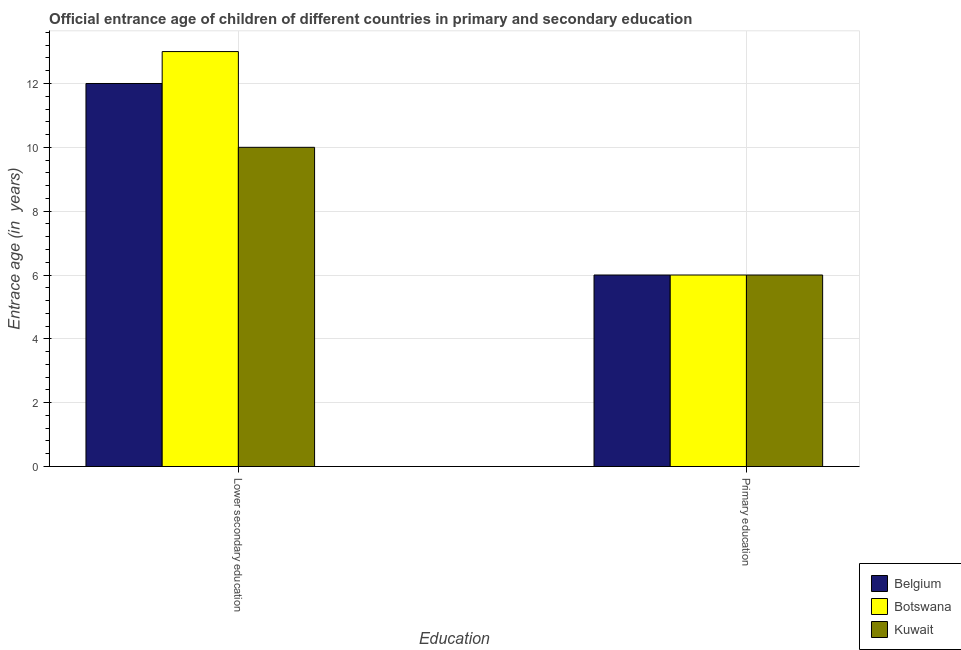How many different coloured bars are there?
Keep it short and to the point. 3. How many groups of bars are there?
Make the answer very short. 2. Are the number of bars on each tick of the X-axis equal?
Make the answer very short. Yes. How many bars are there on the 1st tick from the left?
Ensure brevity in your answer.  3. How many bars are there on the 2nd tick from the right?
Your answer should be compact. 3. What is the label of the 1st group of bars from the left?
Your answer should be very brief. Lower secondary education. What is the entrance age of chiildren in primary education in Belgium?
Keep it short and to the point. 6. Across all countries, what is the maximum entrance age of chiildren in primary education?
Your response must be concise. 6. Across all countries, what is the minimum entrance age of chiildren in primary education?
Make the answer very short. 6. In which country was the entrance age of children in lower secondary education maximum?
Your response must be concise. Botswana. In which country was the entrance age of chiildren in primary education minimum?
Give a very brief answer. Belgium. What is the total entrance age of chiildren in primary education in the graph?
Keep it short and to the point. 18. What is the difference between the entrance age of chiildren in primary education in Kuwait and that in Botswana?
Offer a terse response. 0. What is the difference between the entrance age of chiildren in primary education in Kuwait and the entrance age of children in lower secondary education in Belgium?
Offer a terse response. -6. What is the average entrance age of children in lower secondary education per country?
Make the answer very short. 11.67. In how many countries, is the entrance age of children in lower secondary education greater than 8 years?
Provide a short and direct response. 3. What is the ratio of the entrance age of chiildren in primary education in Belgium to that in Botswana?
Give a very brief answer. 1. Is the entrance age of chiildren in primary education in Botswana less than that in Kuwait?
Ensure brevity in your answer.  No. In how many countries, is the entrance age of children in lower secondary education greater than the average entrance age of children in lower secondary education taken over all countries?
Your answer should be very brief. 2. What does the 3rd bar from the left in Lower secondary education represents?
Provide a short and direct response. Kuwait. Are all the bars in the graph horizontal?
Provide a succinct answer. No. How many countries are there in the graph?
Make the answer very short. 3. What is the difference between two consecutive major ticks on the Y-axis?
Your response must be concise. 2. Are the values on the major ticks of Y-axis written in scientific E-notation?
Your response must be concise. No. Does the graph contain grids?
Provide a short and direct response. Yes. Where does the legend appear in the graph?
Provide a succinct answer. Bottom right. How many legend labels are there?
Make the answer very short. 3. What is the title of the graph?
Ensure brevity in your answer.  Official entrance age of children of different countries in primary and secondary education. Does "Serbia" appear as one of the legend labels in the graph?
Keep it short and to the point. No. What is the label or title of the X-axis?
Offer a very short reply. Education. What is the label or title of the Y-axis?
Offer a very short reply. Entrace age (in  years). What is the Entrace age (in  years) in Botswana in Lower secondary education?
Provide a short and direct response. 13. What is the Entrace age (in  years) in Kuwait in Lower secondary education?
Ensure brevity in your answer.  10. What is the Entrace age (in  years) in Kuwait in Primary education?
Your answer should be very brief. 6. What is the total Entrace age (in  years) in Belgium in the graph?
Give a very brief answer. 18. What is the difference between the Entrace age (in  years) of Belgium in Lower secondary education and that in Primary education?
Your answer should be very brief. 6. What is the difference between the Entrace age (in  years) of Kuwait in Lower secondary education and that in Primary education?
Your response must be concise. 4. What is the difference between the Entrace age (in  years) in Belgium in Lower secondary education and the Entrace age (in  years) in Kuwait in Primary education?
Give a very brief answer. 6. What is the average Entrace age (in  years) in Botswana per Education?
Offer a terse response. 9.5. What is the difference between the Entrace age (in  years) of Belgium and Entrace age (in  years) of Botswana in Lower secondary education?
Provide a short and direct response. -1. What is the difference between the Entrace age (in  years) in Belgium and Entrace age (in  years) in Kuwait in Lower secondary education?
Give a very brief answer. 2. What is the difference between the Entrace age (in  years) of Belgium and Entrace age (in  years) of Botswana in Primary education?
Keep it short and to the point. 0. What is the ratio of the Entrace age (in  years) in Belgium in Lower secondary education to that in Primary education?
Your response must be concise. 2. What is the ratio of the Entrace age (in  years) in Botswana in Lower secondary education to that in Primary education?
Your response must be concise. 2.17. What is the ratio of the Entrace age (in  years) of Kuwait in Lower secondary education to that in Primary education?
Your response must be concise. 1.67. What is the difference between the highest and the second highest Entrace age (in  years) in Botswana?
Your answer should be compact. 7. What is the difference between the highest and the second highest Entrace age (in  years) in Kuwait?
Offer a very short reply. 4. What is the difference between the highest and the lowest Entrace age (in  years) in Botswana?
Offer a terse response. 7. What is the difference between the highest and the lowest Entrace age (in  years) in Kuwait?
Offer a very short reply. 4. 